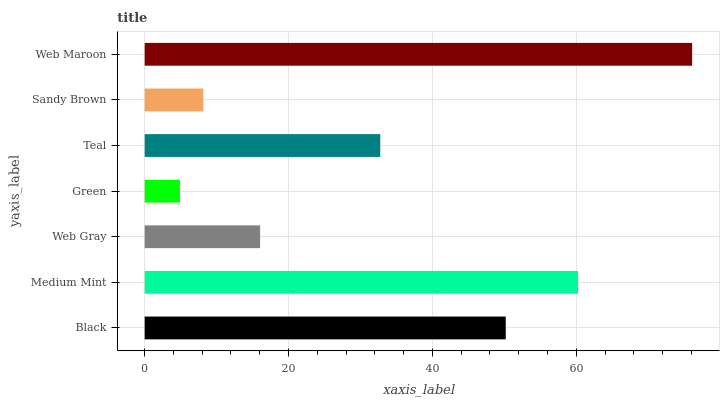Is Green the minimum?
Answer yes or no. Yes. Is Web Maroon the maximum?
Answer yes or no. Yes. Is Medium Mint the minimum?
Answer yes or no. No. Is Medium Mint the maximum?
Answer yes or no. No. Is Medium Mint greater than Black?
Answer yes or no. Yes. Is Black less than Medium Mint?
Answer yes or no. Yes. Is Black greater than Medium Mint?
Answer yes or no. No. Is Medium Mint less than Black?
Answer yes or no. No. Is Teal the high median?
Answer yes or no. Yes. Is Teal the low median?
Answer yes or no. Yes. Is Medium Mint the high median?
Answer yes or no. No. Is Web Maroon the low median?
Answer yes or no. No. 